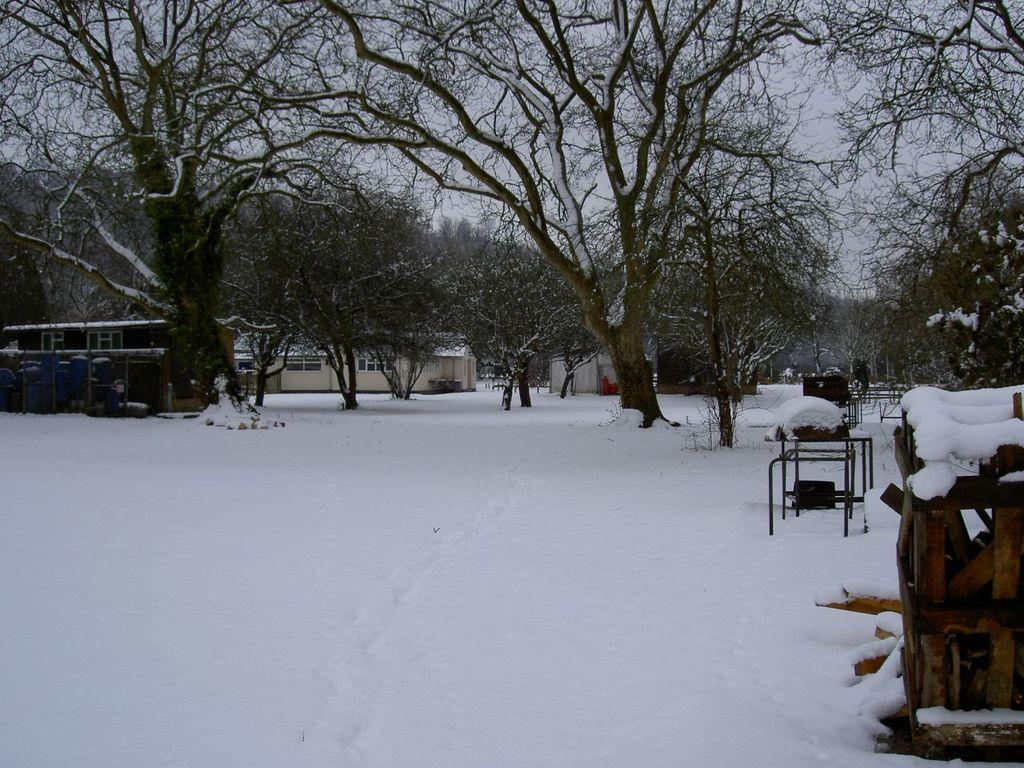What type of weather is depicted in the image? There is snow in the image, indicating a winter scene. What structures can be seen in the image? There are buildings in the image. What type of vegetation is present in the image? There are trees in the image. What is visible at the top of the image? The sky is visible at the top of the image. What verse can be heard recited by the animal in the image? There is no animal present in the image, and therefore no verse can be heard. What type of insurance policy is being discussed by the people in the image? There are no people present in the image, and therefore no insurance policy is being discussed. 